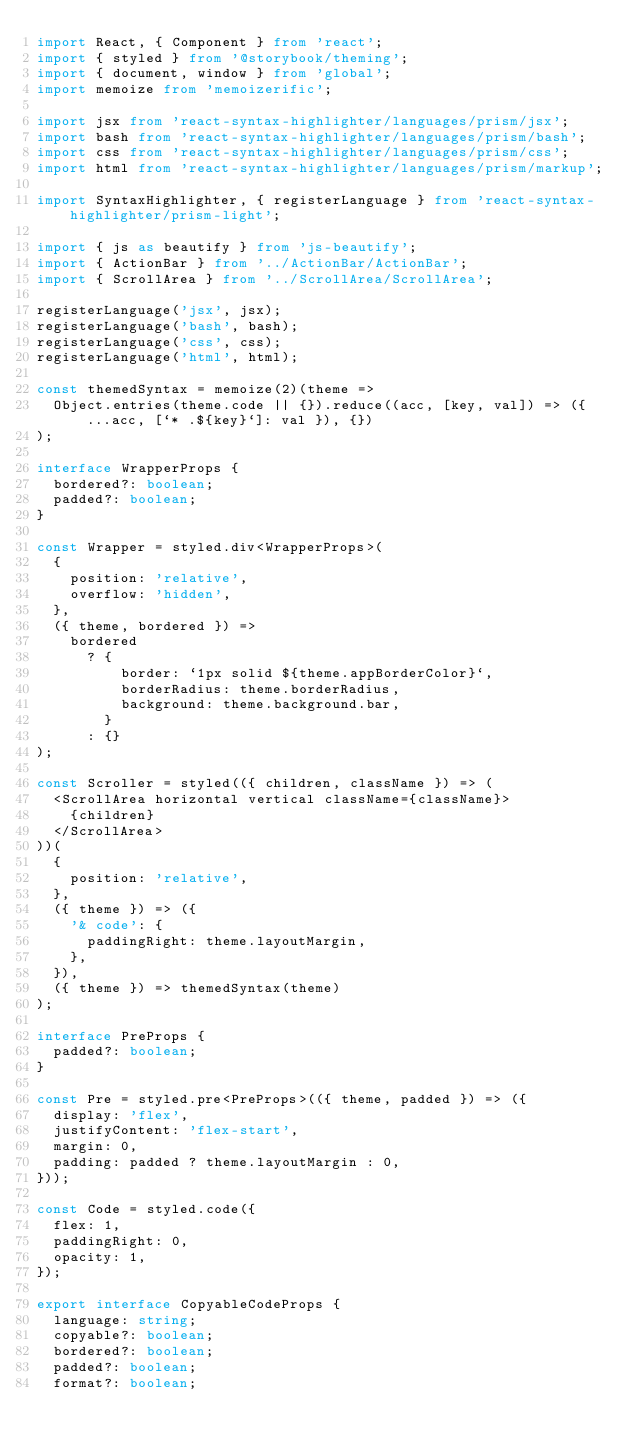<code> <loc_0><loc_0><loc_500><loc_500><_TypeScript_>import React, { Component } from 'react';
import { styled } from '@storybook/theming';
import { document, window } from 'global';
import memoize from 'memoizerific';

import jsx from 'react-syntax-highlighter/languages/prism/jsx';
import bash from 'react-syntax-highlighter/languages/prism/bash';
import css from 'react-syntax-highlighter/languages/prism/css';
import html from 'react-syntax-highlighter/languages/prism/markup';

import SyntaxHighlighter, { registerLanguage } from 'react-syntax-highlighter/prism-light';

import { js as beautify } from 'js-beautify';
import { ActionBar } from '../ActionBar/ActionBar';
import { ScrollArea } from '../ScrollArea/ScrollArea';

registerLanguage('jsx', jsx);
registerLanguage('bash', bash);
registerLanguage('css', css);
registerLanguage('html', html);

const themedSyntax = memoize(2)(theme =>
  Object.entries(theme.code || {}).reduce((acc, [key, val]) => ({ ...acc, [`* .${key}`]: val }), {})
);

interface WrapperProps {
  bordered?: boolean;
  padded?: boolean;
}

const Wrapper = styled.div<WrapperProps>(
  {
    position: 'relative',
    overflow: 'hidden',
  },
  ({ theme, bordered }) =>
    bordered
      ? {
          border: `1px solid ${theme.appBorderColor}`,
          borderRadius: theme.borderRadius,
          background: theme.background.bar,
        }
      : {}
);

const Scroller = styled(({ children, className }) => (
  <ScrollArea horizontal vertical className={className}>
    {children}
  </ScrollArea>
))(
  {
    position: 'relative',
  },
  ({ theme }) => ({
    '& code': {
      paddingRight: theme.layoutMargin,
    },
  }),
  ({ theme }) => themedSyntax(theme)
);

interface PreProps {
  padded?: boolean;
}

const Pre = styled.pre<PreProps>(({ theme, padded }) => ({
  display: 'flex',
  justifyContent: 'flex-start',
  margin: 0,
  padding: padded ? theme.layoutMargin : 0,
}));

const Code = styled.code({
  flex: 1,
  paddingRight: 0,
  opacity: 1,
});

export interface CopyableCodeProps {
  language: string;
  copyable?: boolean;
  bordered?: boolean;
  padded?: boolean;
  format?: boolean;</code> 